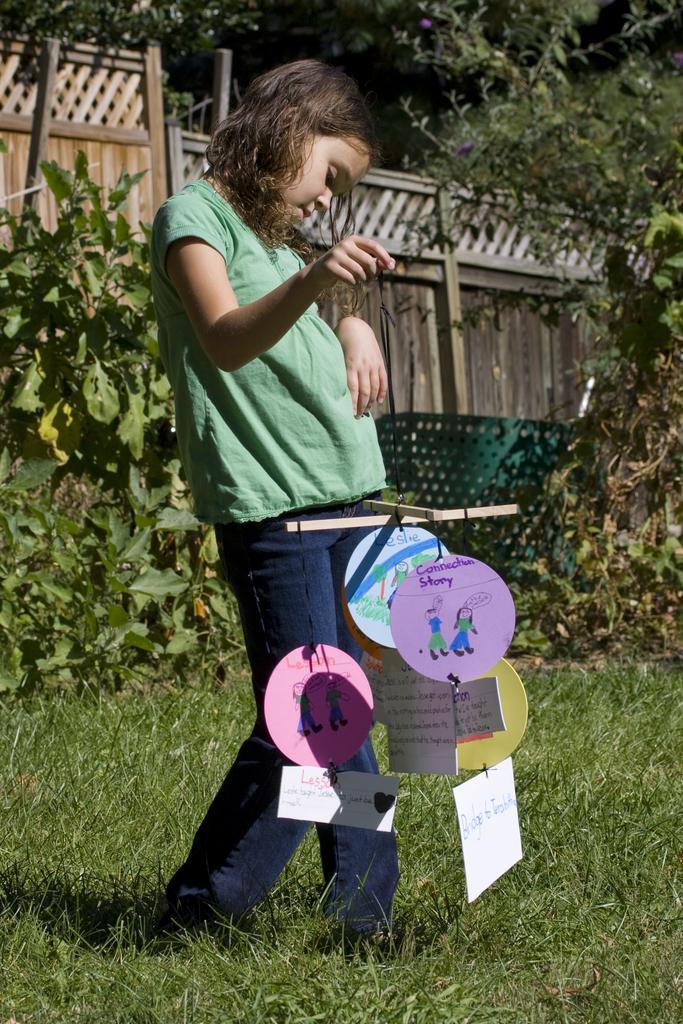Please provide a concise description of this image. In this image we can see a person standing and the person is holding a thread. To the thread there are few papers are attached and on the papers we can see some text and images. Behind the person we can see few plants and wooden fencing. At the top we can see few trees. At the bottom we can see the grass. 